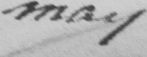Please transcribe the handwritten text in this image. may 